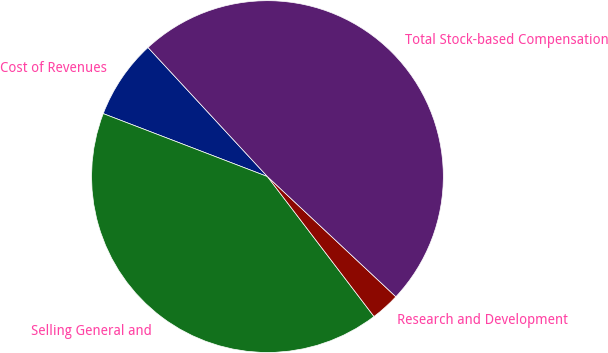<chart> <loc_0><loc_0><loc_500><loc_500><pie_chart><fcel>Cost of Revenues<fcel>Selling General and<fcel>Research and Development<fcel>Total Stock-based Compensation<nl><fcel>7.29%<fcel>41.18%<fcel>2.67%<fcel>48.85%<nl></chart> 